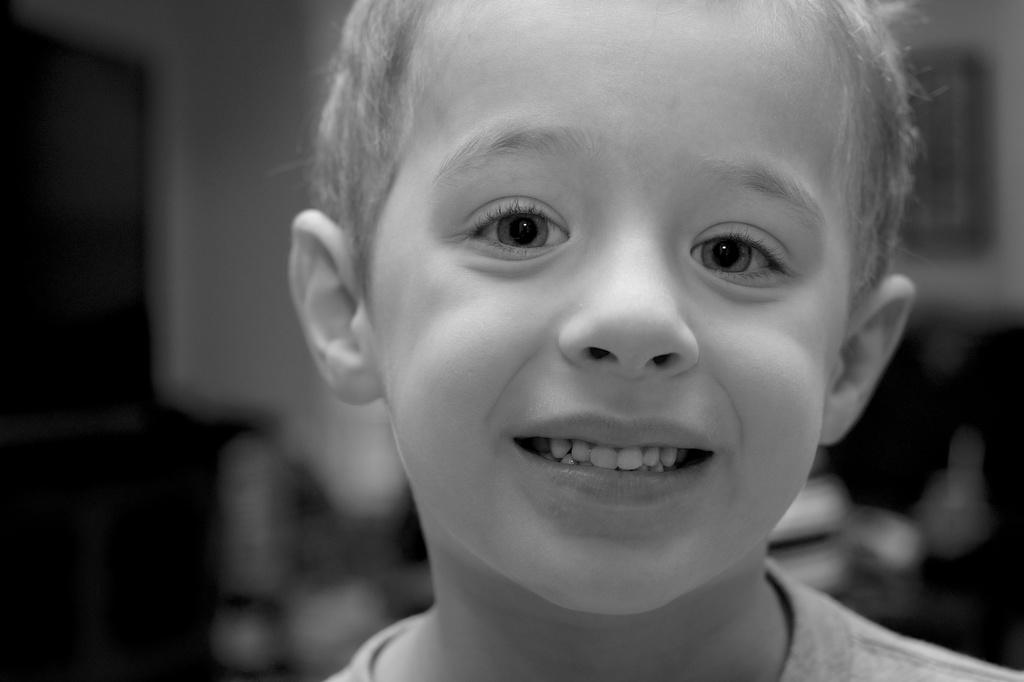What is the color scheme of the image? The image is black and white. Who is present in the image? There is a kid in the image. What is the kid's expression in the image? The kid is smiling. Can you describe the background of the image? The background of the image is blurred. What type of toe is visible in the image? There is no toe present in the image. What is the kid using to water the plants in the image? There is no hose or watering activity depicted in the image. 